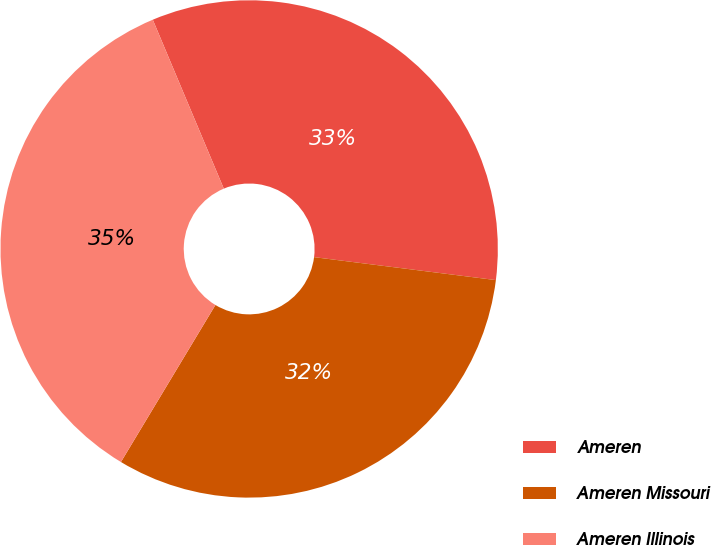<chart> <loc_0><loc_0><loc_500><loc_500><pie_chart><fcel>Ameren<fcel>Ameren Missouri<fcel>Ameren Illinois<nl><fcel>33.33%<fcel>31.62%<fcel>35.04%<nl></chart> 